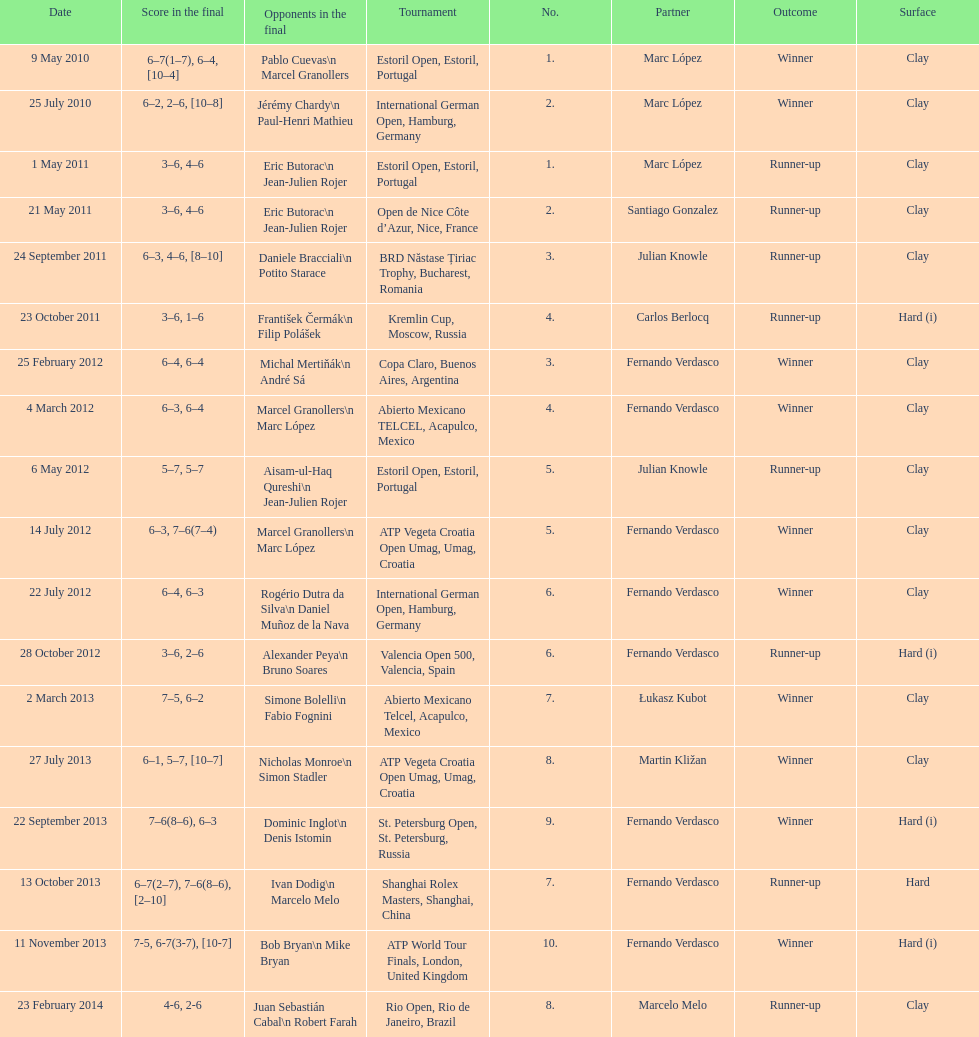What is the number of winning outcomes? 10. 